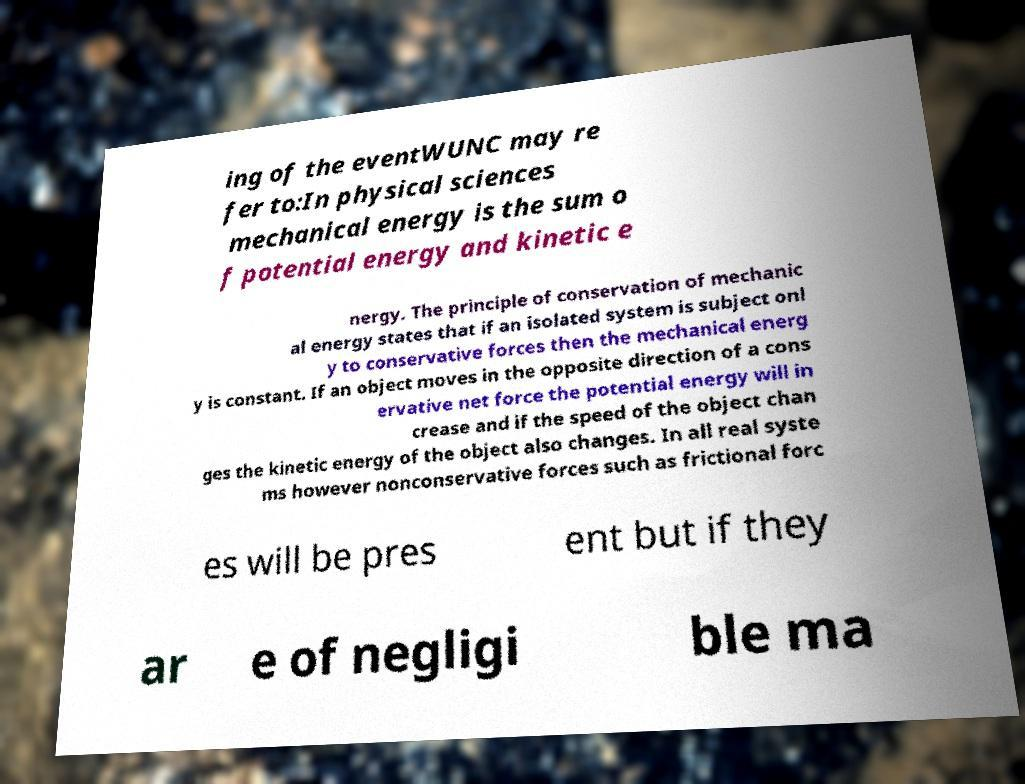Please identify and transcribe the text found in this image. ing of the eventWUNC may re fer to:In physical sciences mechanical energy is the sum o f potential energy and kinetic e nergy. The principle of conservation of mechanic al energy states that if an isolated system is subject onl y to conservative forces then the mechanical energ y is constant. If an object moves in the opposite direction of a cons ervative net force the potential energy will in crease and if the speed of the object chan ges the kinetic energy of the object also changes. In all real syste ms however nonconservative forces such as frictional forc es will be pres ent but if they ar e of negligi ble ma 